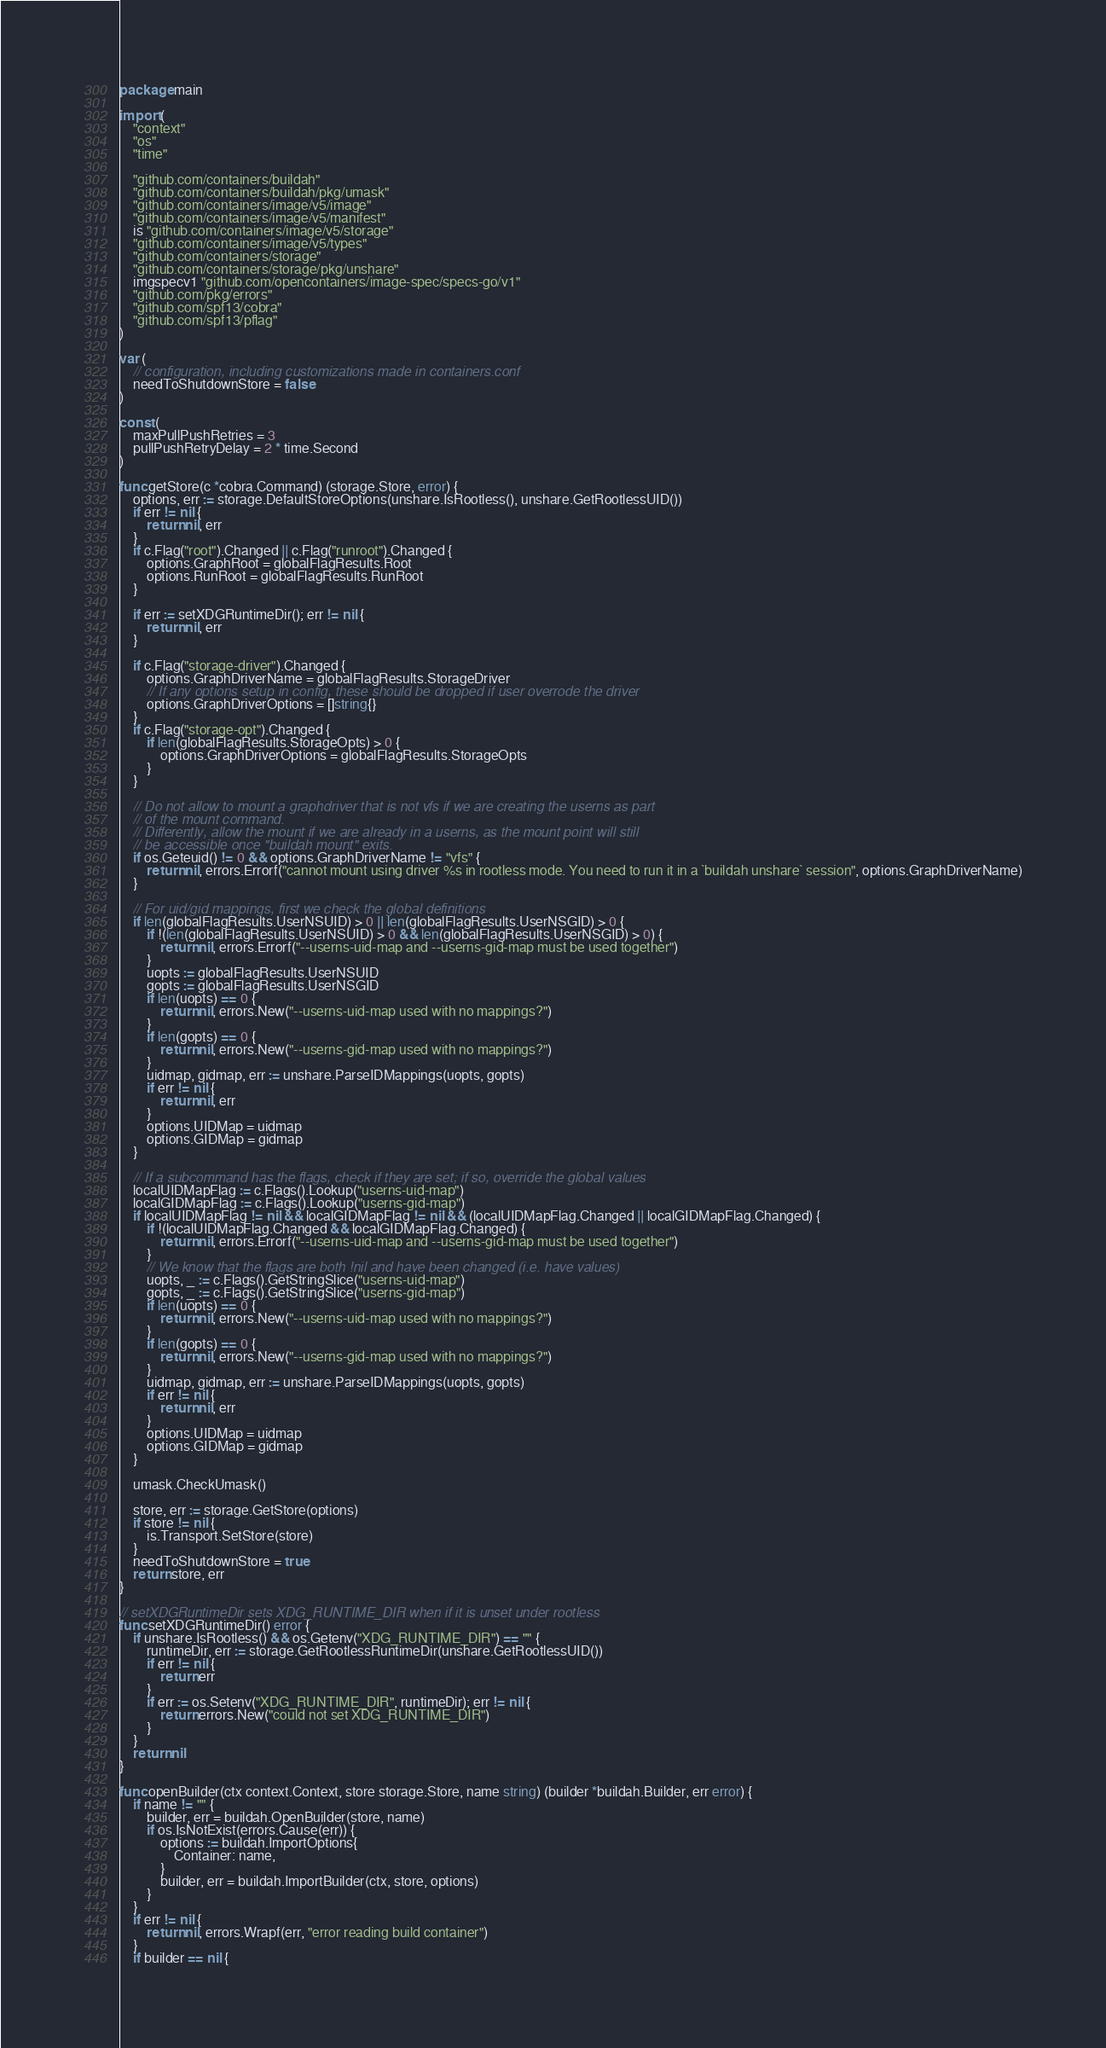<code> <loc_0><loc_0><loc_500><loc_500><_Go_>package main

import (
	"context"
	"os"
	"time"

	"github.com/containers/buildah"
	"github.com/containers/buildah/pkg/umask"
	"github.com/containers/image/v5/image"
	"github.com/containers/image/v5/manifest"
	is "github.com/containers/image/v5/storage"
	"github.com/containers/image/v5/types"
	"github.com/containers/storage"
	"github.com/containers/storage/pkg/unshare"
	imgspecv1 "github.com/opencontainers/image-spec/specs-go/v1"
	"github.com/pkg/errors"
	"github.com/spf13/cobra"
	"github.com/spf13/pflag"
)

var (
	// configuration, including customizations made in containers.conf
	needToShutdownStore = false
)

const (
	maxPullPushRetries = 3
	pullPushRetryDelay = 2 * time.Second
)

func getStore(c *cobra.Command) (storage.Store, error) {
	options, err := storage.DefaultStoreOptions(unshare.IsRootless(), unshare.GetRootlessUID())
	if err != nil {
		return nil, err
	}
	if c.Flag("root").Changed || c.Flag("runroot").Changed {
		options.GraphRoot = globalFlagResults.Root
		options.RunRoot = globalFlagResults.RunRoot
	}

	if err := setXDGRuntimeDir(); err != nil {
		return nil, err
	}

	if c.Flag("storage-driver").Changed {
		options.GraphDriverName = globalFlagResults.StorageDriver
		// If any options setup in config, these should be dropped if user overrode the driver
		options.GraphDriverOptions = []string{}
	}
	if c.Flag("storage-opt").Changed {
		if len(globalFlagResults.StorageOpts) > 0 {
			options.GraphDriverOptions = globalFlagResults.StorageOpts
		}
	}

	// Do not allow to mount a graphdriver that is not vfs if we are creating the userns as part
	// of the mount command.
	// Differently, allow the mount if we are already in a userns, as the mount point will still
	// be accessible once "buildah mount" exits.
	if os.Geteuid() != 0 && options.GraphDriverName != "vfs" {
		return nil, errors.Errorf("cannot mount using driver %s in rootless mode. You need to run it in a `buildah unshare` session", options.GraphDriverName)
	}

	// For uid/gid mappings, first we check the global definitions
	if len(globalFlagResults.UserNSUID) > 0 || len(globalFlagResults.UserNSGID) > 0 {
		if !(len(globalFlagResults.UserNSUID) > 0 && len(globalFlagResults.UserNSGID) > 0) {
			return nil, errors.Errorf("--userns-uid-map and --userns-gid-map must be used together")
		}
		uopts := globalFlagResults.UserNSUID
		gopts := globalFlagResults.UserNSGID
		if len(uopts) == 0 {
			return nil, errors.New("--userns-uid-map used with no mappings?")
		}
		if len(gopts) == 0 {
			return nil, errors.New("--userns-gid-map used with no mappings?")
		}
		uidmap, gidmap, err := unshare.ParseIDMappings(uopts, gopts)
		if err != nil {
			return nil, err
		}
		options.UIDMap = uidmap
		options.GIDMap = gidmap
	}

	// If a subcommand has the flags, check if they are set; if so, override the global values
	localUIDMapFlag := c.Flags().Lookup("userns-uid-map")
	localGIDMapFlag := c.Flags().Lookup("userns-gid-map")
	if localUIDMapFlag != nil && localGIDMapFlag != nil && (localUIDMapFlag.Changed || localGIDMapFlag.Changed) {
		if !(localUIDMapFlag.Changed && localGIDMapFlag.Changed) {
			return nil, errors.Errorf("--userns-uid-map and --userns-gid-map must be used together")
		}
		// We know that the flags are both !nil and have been changed (i.e. have values)
		uopts, _ := c.Flags().GetStringSlice("userns-uid-map")
		gopts, _ := c.Flags().GetStringSlice("userns-gid-map")
		if len(uopts) == 0 {
			return nil, errors.New("--userns-uid-map used with no mappings?")
		}
		if len(gopts) == 0 {
			return nil, errors.New("--userns-gid-map used with no mappings?")
		}
		uidmap, gidmap, err := unshare.ParseIDMappings(uopts, gopts)
		if err != nil {
			return nil, err
		}
		options.UIDMap = uidmap
		options.GIDMap = gidmap
	}

	umask.CheckUmask()

	store, err := storage.GetStore(options)
	if store != nil {
		is.Transport.SetStore(store)
	}
	needToShutdownStore = true
	return store, err
}

// setXDGRuntimeDir sets XDG_RUNTIME_DIR when if it is unset under rootless
func setXDGRuntimeDir() error {
	if unshare.IsRootless() && os.Getenv("XDG_RUNTIME_DIR") == "" {
		runtimeDir, err := storage.GetRootlessRuntimeDir(unshare.GetRootlessUID())
		if err != nil {
			return err
		}
		if err := os.Setenv("XDG_RUNTIME_DIR", runtimeDir); err != nil {
			return errors.New("could not set XDG_RUNTIME_DIR")
		}
	}
	return nil
}

func openBuilder(ctx context.Context, store storage.Store, name string) (builder *buildah.Builder, err error) {
	if name != "" {
		builder, err = buildah.OpenBuilder(store, name)
		if os.IsNotExist(errors.Cause(err)) {
			options := buildah.ImportOptions{
				Container: name,
			}
			builder, err = buildah.ImportBuilder(ctx, store, options)
		}
	}
	if err != nil {
		return nil, errors.Wrapf(err, "error reading build container")
	}
	if builder == nil {</code> 